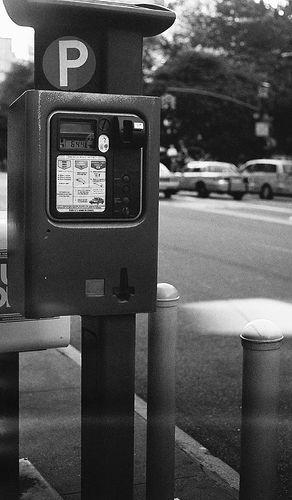What type of machine is this?
Give a very brief answer. Parking. What is this box for?
Concise answer only. Parking. How does one pay at this machine?
Answer briefly. Coins. How many times does the letter P show up in this image?
Give a very brief answer. 1. 